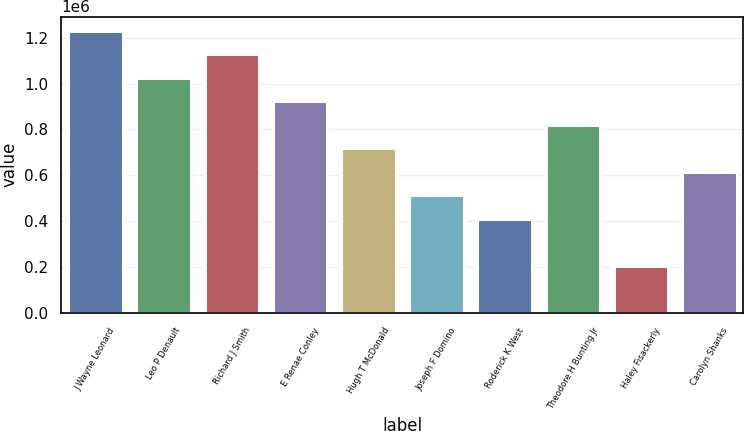<chart> <loc_0><loc_0><loc_500><loc_500><bar_chart><fcel>J Wayne Leonard<fcel>Leo P Denault<fcel>Richard J Smith<fcel>E Renae Conley<fcel>Hugh T McDonald<fcel>Joseph F Domino<fcel>Roderick K West<fcel>Theodore H Bunting Jr<fcel>Haley Fisackerly<fcel>Carolyn Shanks<nl><fcel>1.23e+06<fcel>1.025e+06<fcel>1.1275e+06<fcel>922501<fcel>717502<fcel>512503<fcel>410003<fcel>820002<fcel>205004<fcel>615002<nl></chart> 